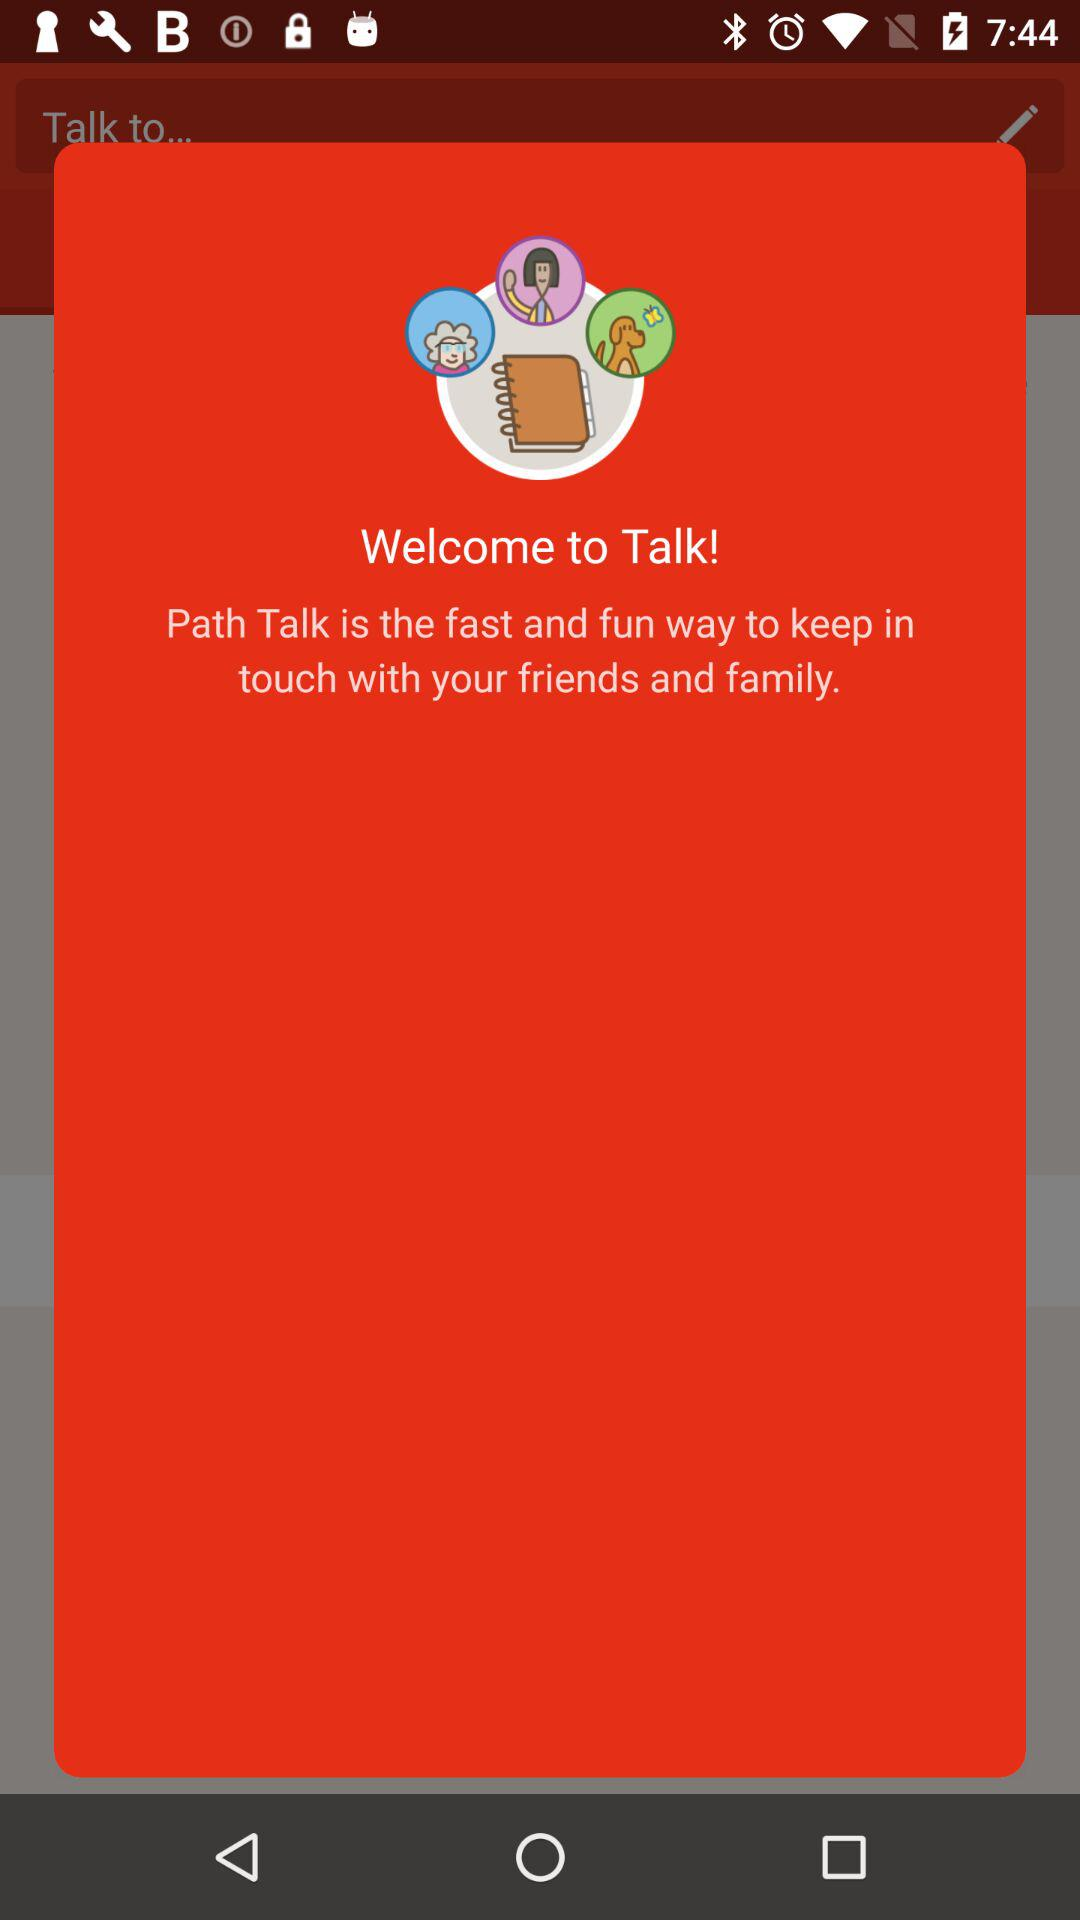What is the name of the application? The name of the application is "Talk!". 